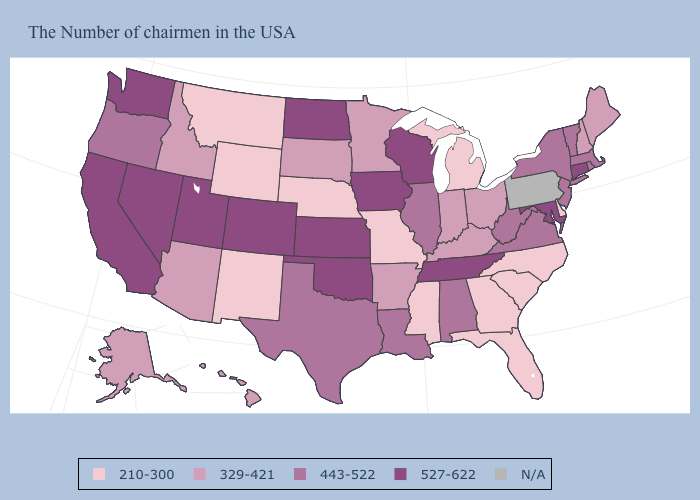Does Florida have the lowest value in the USA?
Be succinct. Yes. What is the lowest value in states that border New Hampshire?
Keep it brief. 329-421. Name the states that have a value in the range 329-421?
Concise answer only. Maine, New Hampshire, Ohio, Kentucky, Indiana, Arkansas, Minnesota, South Dakota, Arizona, Idaho, Alaska, Hawaii. Name the states that have a value in the range 443-522?
Quick response, please. Massachusetts, Rhode Island, Vermont, New York, New Jersey, Virginia, West Virginia, Alabama, Illinois, Louisiana, Texas, Oregon. Which states have the lowest value in the West?
Answer briefly. Wyoming, New Mexico, Montana. Name the states that have a value in the range 443-522?
Give a very brief answer. Massachusetts, Rhode Island, Vermont, New York, New Jersey, Virginia, West Virginia, Alabama, Illinois, Louisiana, Texas, Oregon. What is the lowest value in the MidWest?
Write a very short answer. 210-300. Name the states that have a value in the range N/A?
Short answer required. Pennsylvania. Name the states that have a value in the range 443-522?
Short answer required. Massachusetts, Rhode Island, Vermont, New York, New Jersey, Virginia, West Virginia, Alabama, Illinois, Louisiana, Texas, Oregon. Which states hav the highest value in the West?
Quick response, please. Colorado, Utah, Nevada, California, Washington. What is the value of Arkansas?
Give a very brief answer. 329-421. What is the value of Idaho?
Answer briefly. 329-421. Among the states that border Virginia , does North Carolina have the lowest value?
Answer briefly. Yes. Does Massachusetts have the lowest value in the Northeast?
Write a very short answer. No. What is the lowest value in states that border New Hampshire?
Quick response, please. 329-421. 